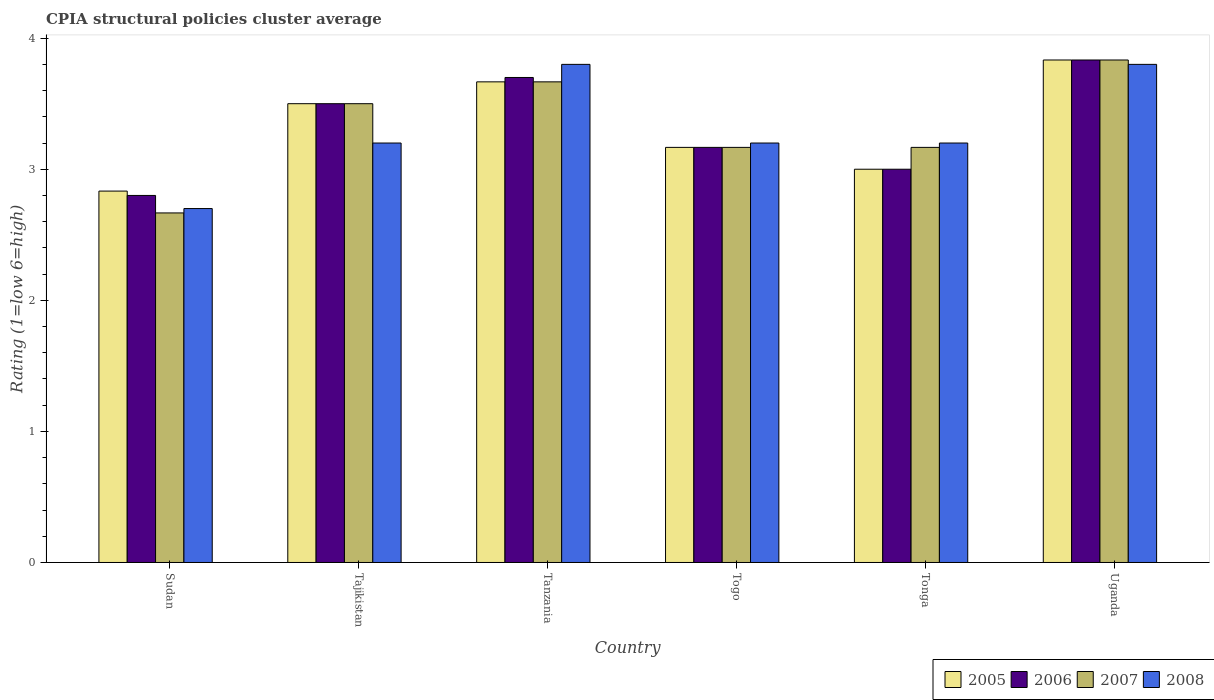Are the number of bars per tick equal to the number of legend labels?
Give a very brief answer. Yes. Are the number of bars on each tick of the X-axis equal?
Your answer should be compact. Yes. How many bars are there on the 2nd tick from the left?
Offer a terse response. 4. What is the label of the 1st group of bars from the left?
Make the answer very short. Sudan. In how many cases, is the number of bars for a given country not equal to the number of legend labels?
Your answer should be very brief. 0. What is the CPIA rating in 2007 in Togo?
Offer a terse response. 3.17. Across all countries, what is the maximum CPIA rating in 2005?
Make the answer very short. 3.83. Across all countries, what is the minimum CPIA rating in 2007?
Offer a terse response. 2.67. In which country was the CPIA rating in 2005 maximum?
Provide a short and direct response. Uganda. In which country was the CPIA rating in 2006 minimum?
Provide a short and direct response. Sudan. What is the total CPIA rating in 2008 in the graph?
Your answer should be compact. 19.9. What is the difference between the CPIA rating in 2008 in Togo and that in Uganda?
Ensure brevity in your answer.  -0.6. What is the difference between the CPIA rating in 2007 in Tanzania and the CPIA rating in 2005 in Togo?
Keep it short and to the point. 0.5. What is the average CPIA rating in 2007 per country?
Make the answer very short. 3.33. What is the difference between the CPIA rating of/in 2005 and CPIA rating of/in 2006 in Sudan?
Your response must be concise. 0.03. What is the ratio of the CPIA rating in 2007 in Tanzania to that in Tonga?
Your answer should be very brief. 1.16. What is the difference between the highest and the second highest CPIA rating in 2008?
Offer a terse response. -0.6. What is the difference between the highest and the lowest CPIA rating in 2008?
Provide a succinct answer. 1.1. In how many countries, is the CPIA rating in 2006 greater than the average CPIA rating in 2006 taken over all countries?
Keep it short and to the point. 3. Is the sum of the CPIA rating in 2008 in Tajikistan and Tonga greater than the maximum CPIA rating in 2007 across all countries?
Offer a very short reply. Yes. Is it the case that in every country, the sum of the CPIA rating in 2005 and CPIA rating in 2008 is greater than the sum of CPIA rating in 2006 and CPIA rating in 2007?
Your answer should be very brief. No. Is it the case that in every country, the sum of the CPIA rating in 2007 and CPIA rating in 2008 is greater than the CPIA rating in 2005?
Offer a terse response. Yes. How many bars are there?
Your answer should be compact. 24. Are all the bars in the graph horizontal?
Provide a short and direct response. No. How many countries are there in the graph?
Your response must be concise. 6. Does the graph contain grids?
Provide a short and direct response. No. Where does the legend appear in the graph?
Give a very brief answer. Bottom right. How many legend labels are there?
Provide a short and direct response. 4. How are the legend labels stacked?
Provide a succinct answer. Horizontal. What is the title of the graph?
Provide a short and direct response. CPIA structural policies cluster average. What is the Rating (1=low 6=high) in 2005 in Sudan?
Keep it short and to the point. 2.83. What is the Rating (1=low 6=high) in 2007 in Sudan?
Provide a short and direct response. 2.67. What is the Rating (1=low 6=high) in 2005 in Tajikistan?
Provide a short and direct response. 3.5. What is the Rating (1=low 6=high) of 2007 in Tajikistan?
Provide a succinct answer. 3.5. What is the Rating (1=low 6=high) in 2008 in Tajikistan?
Provide a short and direct response. 3.2. What is the Rating (1=low 6=high) of 2005 in Tanzania?
Ensure brevity in your answer.  3.67. What is the Rating (1=low 6=high) of 2006 in Tanzania?
Your response must be concise. 3.7. What is the Rating (1=low 6=high) of 2007 in Tanzania?
Give a very brief answer. 3.67. What is the Rating (1=low 6=high) in 2005 in Togo?
Your answer should be compact. 3.17. What is the Rating (1=low 6=high) of 2006 in Togo?
Your answer should be very brief. 3.17. What is the Rating (1=low 6=high) in 2007 in Togo?
Your answer should be compact. 3.17. What is the Rating (1=low 6=high) in 2007 in Tonga?
Your answer should be compact. 3.17. What is the Rating (1=low 6=high) of 2005 in Uganda?
Offer a terse response. 3.83. What is the Rating (1=low 6=high) of 2006 in Uganda?
Give a very brief answer. 3.83. What is the Rating (1=low 6=high) in 2007 in Uganda?
Provide a short and direct response. 3.83. What is the Rating (1=low 6=high) in 2008 in Uganda?
Your answer should be very brief. 3.8. Across all countries, what is the maximum Rating (1=low 6=high) in 2005?
Your answer should be compact. 3.83. Across all countries, what is the maximum Rating (1=low 6=high) of 2006?
Your answer should be compact. 3.83. Across all countries, what is the maximum Rating (1=low 6=high) in 2007?
Your response must be concise. 3.83. Across all countries, what is the maximum Rating (1=low 6=high) in 2008?
Offer a very short reply. 3.8. Across all countries, what is the minimum Rating (1=low 6=high) in 2005?
Offer a very short reply. 2.83. Across all countries, what is the minimum Rating (1=low 6=high) in 2007?
Offer a terse response. 2.67. Across all countries, what is the minimum Rating (1=low 6=high) of 2008?
Provide a short and direct response. 2.7. What is the total Rating (1=low 6=high) of 2007 in the graph?
Offer a terse response. 20. What is the total Rating (1=low 6=high) of 2008 in the graph?
Your answer should be compact. 19.9. What is the difference between the Rating (1=low 6=high) in 2005 in Sudan and that in Tanzania?
Make the answer very short. -0.83. What is the difference between the Rating (1=low 6=high) of 2007 in Sudan and that in Tanzania?
Your answer should be compact. -1. What is the difference between the Rating (1=low 6=high) of 2008 in Sudan and that in Tanzania?
Provide a short and direct response. -1.1. What is the difference between the Rating (1=low 6=high) of 2005 in Sudan and that in Togo?
Offer a terse response. -0.33. What is the difference between the Rating (1=low 6=high) of 2006 in Sudan and that in Togo?
Your response must be concise. -0.37. What is the difference between the Rating (1=low 6=high) in 2007 in Sudan and that in Togo?
Offer a very short reply. -0.5. What is the difference between the Rating (1=low 6=high) of 2008 in Sudan and that in Togo?
Make the answer very short. -0.5. What is the difference between the Rating (1=low 6=high) of 2005 in Sudan and that in Tonga?
Your answer should be compact. -0.17. What is the difference between the Rating (1=low 6=high) of 2007 in Sudan and that in Tonga?
Give a very brief answer. -0.5. What is the difference between the Rating (1=low 6=high) in 2008 in Sudan and that in Tonga?
Ensure brevity in your answer.  -0.5. What is the difference between the Rating (1=low 6=high) of 2006 in Sudan and that in Uganda?
Your answer should be compact. -1.03. What is the difference between the Rating (1=low 6=high) of 2007 in Sudan and that in Uganda?
Keep it short and to the point. -1.17. What is the difference between the Rating (1=low 6=high) of 2008 in Sudan and that in Uganda?
Keep it short and to the point. -1.1. What is the difference between the Rating (1=low 6=high) of 2005 in Tajikistan and that in Tanzania?
Offer a very short reply. -0.17. What is the difference between the Rating (1=low 6=high) of 2006 in Tajikistan and that in Tanzania?
Keep it short and to the point. -0.2. What is the difference between the Rating (1=low 6=high) in 2005 in Tajikistan and that in Togo?
Provide a succinct answer. 0.33. What is the difference between the Rating (1=low 6=high) in 2006 in Tajikistan and that in Togo?
Your answer should be very brief. 0.33. What is the difference between the Rating (1=low 6=high) in 2008 in Tajikistan and that in Togo?
Your response must be concise. 0. What is the difference between the Rating (1=low 6=high) in 2005 in Tajikistan and that in Tonga?
Ensure brevity in your answer.  0.5. What is the difference between the Rating (1=low 6=high) in 2006 in Tajikistan and that in Tonga?
Your answer should be compact. 0.5. What is the difference between the Rating (1=low 6=high) in 2006 in Tajikistan and that in Uganda?
Your answer should be compact. -0.33. What is the difference between the Rating (1=low 6=high) of 2007 in Tajikistan and that in Uganda?
Your response must be concise. -0.33. What is the difference between the Rating (1=low 6=high) in 2008 in Tajikistan and that in Uganda?
Make the answer very short. -0.6. What is the difference between the Rating (1=low 6=high) in 2006 in Tanzania and that in Togo?
Give a very brief answer. 0.53. What is the difference between the Rating (1=low 6=high) in 2007 in Tanzania and that in Togo?
Make the answer very short. 0.5. What is the difference between the Rating (1=low 6=high) of 2005 in Tanzania and that in Tonga?
Give a very brief answer. 0.67. What is the difference between the Rating (1=low 6=high) of 2006 in Tanzania and that in Tonga?
Keep it short and to the point. 0.7. What is the difference between the Rating (1=low 6=high) of 2007 in Tanzania and that in Tonga?
Make the answer very short. 0.5. What is the difference between the Rating (1=low 6=high) in 2006 in Tanzania and that in Uganda?
Offer a very short reply. -0.13. What is the difference between the Rating (1=low 6=high) in 2007 in Tanzania and that in Uganda?
Offer a very short reply. -0.17. What is the difference between the Rating (1=low 6=high) of 2008 in Tanzania and that in Uganda?
Your answer should be compact. 0. What is the difference between the Rating (1=low 6=high) in 2005 in Togo and that in Tonga?
Keep it short and to the point. 0.17. What is the difference between the Rating (1=low 6=high) in 2007 in Togo and that in Tonga?
Offer a very short reply. 0. What is the difference between the Rating (1=low 6=high) of 2005 in Togo and that in Uganda?
Keep it short and to the point. -0.67. What is the difference between the Rating (1=low 6=high) of 2006 in Tonga and that in Uganda?
Keep it short and to the point. -0.83. What is the difference between the Rating (1=low 6=high) in 2005 in Sudan and the Rating (1=low 6=high) in 2008 in Tajikistan?
Keep it short and to the point. -0.37. What is the difference between the Rating (1=low 6=high) of 2007 in Sudan and the Rating (1=low 6=high) of 2008 in Tajikistan?
Your response must be concise. -0.53. What is the difference between the Rating (1=low 6=high) in 2005 in Sudan and the Rating (1=low 6=high) in 2006 in Tanzania?
Your response must be concise. -0.87. What is the difference between the Rating (1=low 6=high) in 2005 in Sudan and the Rating (1=low 6=high) in 2008 in Tanzania?
Your response must be concise. -0.97. What is the difference between the Rating (1=low 6=high) in 2006 in Sudan and the Rating (1=low 6=high) in 2007 in Tanzania?
Your response must be concise. -0.87. What is the difference between the Rating (1=low 6=high) in 2006 in Sudan and the Rating (1=low 6=high) in 2008 in Tanzania?
Your response must be concise. -1. What is the difference between the Rating (1=low 6=high) of 2007 in Sudan and the Rating (1=low 6=high) of 2008 in Tanzania?
Keep it short and to the point. -1.13. What is the difference between the Rating (1=low 6=high) in 2005 in Sudan and the Rating (1=low 6=high) in 2007 in Togo?
Your answer should be compact. -0.33. What is the difference between the Rating (1=low 6=high) in 2005 in Sudan and the Rating (1=low 6=high) in 2008 in Togo?
Your response must be concise. -0.37. What is the difference between the Rating (1=low 6=high) of 2006 in Sudan and the Rating (1=low 6=high) of 2007 in Togo?
Provide a succinct answer. -0.37. What is the difference between the Rating (1=low 6=high) of 2007 in Sudan and the Rating (1=low 6=high) of 2008 in Togo?
Give a very brief answer. -0.53. What is the difference between the Rating (1=low 6=high) of 2005 in Sudan and the Rating (1=low 6=high) of 2007 in Tonga?
Provide a short and direct response. -0.33. What is the difference between the Rating (1=low 6=high) of 2005 in Sudan and the Rating (1=low 6=high) of 2008 in Tonga?
Provide a succinct answer. -0.37. What is the difference between the Rating (1=low 6=high) of 2006 in Sudan and the Rating (1=low 6=high) of 2007 in Tonga?
Make the answer very short. -0.37. What is the difference between the Rating (1=low 6=high) of 2006 in Sudan and the Rating (1=low 6=high) of 2008 in Tonga?
Provide a succinct answer. -0.4. What is the difference between the Rating (1=low 6=high) of 2007 in Sudan and the Rating (1=low 6=high) of 2008 in Tonga?
Provide a short and direct response. -0.53. What is the difference between the Rating (1=low 6=high) of 2005 in Sudan and the Rating (1=low 6=high) of 2007 in Uganda?
Keep it short and to the point. -1. What is the difference between the Rating (1=low 6=high) in 2005 in Sudan and the Rating (1=low 6=high) in 2008 in Uganda?
Your answer should be compact. -0.97. What is the difference between the Rating (1=low 6=high) of 2006 in Sudan and the Rating (1=low 6=high) of 2007 in Uganda?
Your response must be concise. -1.03. What is the difference between the Rating (1=low 6=high) in 2006 in Sudan and the Rating (1=low 6=high) in 2008 in Uganda?
Provide a short and direct response. -1. What is the difference between the Rating (1=low 6=high) of 2007 in Sudan and the Rating (1=low 6=high) of 2008 in Uganda?
Your answer should be compact. -1.13. What is the difference between the Rating (1=low 6=high) of 2005 in Tajikistan and the Rating (1=low 6=high) of 2006 in Tanzania?
Provide a succinct answer. -0.2. What is the difference between the Rating (1=low 6=high) of 2005 in Tajikistan and the Rating (1=low 6=high) of 2007 in Tanzania?
Ensure brevity in your answer.  -0.17. What is the difference between the Rating (1=low 6=high) in 2006 in Tajikistan and the Rating (1=low 6=high) in 2007 in Tanzania?
Offer a terse response. -0.17. What is the difference between the Rating (1=low 6=high) in 2005 in Tajikistan and the Rating (1=low 6=high) in 2006 in Togo?
Your answer should be very brief. 0.33. What is the difference between the Rating (1=low 6=high) of 2005 in Tajikistan and the Rating (1=low 6=high) of 2007 in Togo?
Provide a short and direct response. 0.33. What is the difference between the Rating (1=low 6=high) of 2006 in Tajikistan and the Rating (1=low 6=high) of 2008 in Togo?
Provide a short and direct response. 0.3. What is the difference between the Rating (1=low 6=high) in 2007 in Tajikistan and the Rating (1=low 6=high) in 2008 in Togo?
Give a very brief answer. 0.3. What is the difference between the Rating (1=low 6=high) of 2005 in Tajikistan and the Rating (1=low 6=high) of 2006 in Uganda?
Keep it short and to the point. -0.33. What is the difference between the Rating (1=low 6=high) in 2005 in Tajikistan and the Rating (1=low 6=high) in 2007 in Uganda?
Your answer should be compact. -0.33. What is the difference between the Rating (1=low 6=high) of 2006 in Tajikistan and the Rating (1=low 6=high) of 2008 in Uganda?
Your answer should be compact. -0.3. What is the difference between the Rating (1=low 6=high) of 2005 in Tanzania and the Rating (1=low 6=high) of 2008 in Togo?
Your response must be concise. 0.47. What is the difference between the Rating (1=low 6=high) of 2006 in Tanzania and the Rating (1=low 6=high) of 2007 in Togo?
Make the answer very short. 0.53. What is the difference between the Rating (1=low 6=high) of 2007 in Tanzania and the Rating (1=low 6=high) of 2008 in Togo?
Offer a terse response. 0.47. What is the difference between the Rating (1=low 6=high) of 2005 in Tanzania and the Rating (1=low 6=high) of 2006 in Tonga?
Keep it short and to the point. 0.67. What is the difference between the Rating (1=low 6=high) of 2005 in Tanzania and the Rating (1=low 6=high) of 2008 in Tonga?
Your response must be concise. 0.47. What is the difference between the Rating (1=low 6=high) in 2006 in Tanzania and the Rating (1=low 6=high) in 2007 in Tonga?
Your answer should be compact. 0.53. What is the difference between the Rating (1=low 6=high) of 2006 in Tanzania and the Rating (1=low 6=high) of 2008 in Tonga?
Offer a terse response. 0.5. What is the difference between the Rating (1=low 6=high) of 2007 in Tanzania and the Rating (1=low 6=high) of 2008 in Tonga?
Your answer should be compact. 0.47. What is the difference between the Rating (1=low 6=high) of 2005 in Tanzania and the Rating (1=low 6=high) of 2006 in Uganda?
Your answer should be compact. -0.17. What is the difference between the Rating (1=low 6=high) in 2005 in Tanzania and the Rating (1=low 6=high) in 2007 in Uganda?
Your answer should be very brief. -0.17. What is the difference between the Rating (1=low 6=high) in 2005 in Tanzania and the Rating (1=low 6=high) in 2008 in Uganda?
Offer a terse response. -0.13. What is the difference between the Rating (1=low 6=high) of 2006 in Tanzania and the Rating (1=low 6=high) of 2007 in Uganda?
Your answer should be compact. -0.13. What is the difference between the Rating (1=low 6=high) of 2006 in Tanzania and the Rating (1=low 6=high) of 2008 in Uganda?
Keep it short and to the point. -0.1. What is the difference between the Rating (1=low 6=high) in 2007 in Tanzania and the Rating (1=low 6=high) in 2008 in Uganda?
Your answer should be compact. -0.13. What is the difference between the Rating (1=low 6=high) of 2005 in Togo and the Rating (1=low 6=high) of 2006 in Tonga?
Provide a short and direct response. 0.17. What is the difference between the Rating (1=low 6=high) in 2005 in Togo and the Rating (1=low 6=high) in 2007 in Tonga?
Ensure brevity in your answer.  0. What is the difference between the Rating (1=low 6=high) in 2005 in Togo and the Rating (1=low 6=high) in 2008 in Tonga?
Offer a terse response. -0.03. What is the difference between the Rating (1=low 6=high) of 2006 in Togo and the Rating (1=low 6=high) of 2008 in Tonga?
Your answer should be compact. -0.03. What is the difference between the Rating (1=low 6=high) in 2007 in Togo and the Rating (1=low 6=high) in 2008 in Tonga?
Give a very brief answer. -0.03. What is the difference between the Rating (1=low 6=high) of 2005 in Togo and the Rating (1=low 6=high) of 2008 in Uganda?
Your answer should be compact. -0.63. What is the difference between the Rating (1=low 6=high) of 2006 in Togo and the Rating (1=low 6=high) of 2007 in Uganda?
Keep it short and to the point. -0.67. What is the difference between the Rating (1=low 6=high) in 2006 in Togo and the Rating (1=low 6=high) in 2008 in Uganda?
Your response must be concise. -0.63. What is the difference between the Rating (1=low 6=high) of 2007 in Togo and the Rating (1=low 6=high) of 2008 in Uganda?
Offer a terse response. -0.63. What is the difference between the Rating (1=low 6=high) in 2005 in Tonga and the Rating (1=low 6=high) in 2006 in Uganda?
Ensure brevity in your answer.  -0.83. What is the difference between the Rating (1=low 6=high) of 2006 in Tonga and the Rating (1=low 6=high) of 2007 in Uganda?
Provide a short and direct response. -0.83. What is the difference between the Rating (1=low 6=high) of 2006 in Tonga and the Rating (1=low 6=high) of 2008 in Uganda?
Ensure brevity in your answer.  -0.8. What is the difference between the Rating (1=low 6=high) of 2007 in Tonga and the Rating (1=low 6=high) of 2008 in Uganda?
Provide a succinct answer. -0.63. What is the average Rating (1=low 6=high) of 2007 per country?
Your answer should be very brief. 3.33. What is the average Rating (1=low 6=high) in 2008 per country?
Offer a terse response. 3.32. What is the difference between the Rating (1=low 6=high) of 2005 and Rating (1=low 6=high) of 2006 in Sudan?
Your answer should be compact. 0.03. What is the difference between the Rating (1=low 6=high) of 2005 and Rating (1=low 6=high) of 2008 in Sudan?
Give a very brief answer. 0.13. What is the difference between the Rating (1=low 6=high) in 2006 and Rating (1=low 6=high) in 2007 in Sudan?
Provide a short and direct response. 0.13. What is the difference between the Rating (1=low 6=high) of 2007 and Rating (1=low 6=high) of 2008 in Sudan?
Ensure brevity in your answer.  -0.03. What is the difference between the Rating (1=low 6=high) in 2005 and Rating (1=low 6=high) in 2008 in Tajikistan?
Offer a very short reply. 0.3. What is the difference between the Rating (1=low 6=high) in 2005 and Rating (1=low 6=high) in 2006 in Tanzania?
Provide a succinct answer. -0.03. What is the difference between the Rating (1=low 6=high) of 2005 and Rating (1=low 6=high) of 2008 in Tanzania?
Make the answer very short. -0.13. What is the difference between the Rating (1=low 6=high) in 2007 and Rating (1=low 6=high) in 2008 in Tanzania?
Make the answer very short. -0.13. What is the difference between the Rating (1=low 6=high) in 2005 and Rating (1=low 6=high) in 2006 in Togo?
Offer a terse response. 0. What is the difference between the Rating (1=low 6=high) in 2005 and Rating (1=low 6=high) in 2007 in Togo?
Offer a very short reply. 0. What is the difference between the Rating (1=low 6=high) in 2005 and Rating (1=low 6=high) in 2008 in Togo?
Provide a short and direct response. -0.03. What is the difference between the Rating (1=low 6=high) in 2006 and Rating (1=low 6=high) in 2007 in Togo?
Your answer should be very brief. 0. What is the difference between the Rating (1=low 6=high) of 2006 and Rating (1=low 6=high) of 2008 in Togo?
Your answer should be very brief. -0.03. What is the difference between the Rating (1=low 6=high) of 2007 and Rating (1=low 6=high) of 2008 in Togo?
Your answer should be compact. -0.03. What is the difference between the Rating (1=low 6=high) of 2005 and Rating (1=low 6=high) of 2006 in Tonga?
Give a very brief answer. 0. What is the difference between the Rating (1=low 6=high) in 2005 and Rating (1=low 6=high) in 2007 in Tonga?
Provide a succinct answer. -0.17. What is the difference between the Rating (1=low 6=high) of 2005 and Rating (1=low 6=high) of 2008 in Tonga?
Keep it short and to the point. -0.2. What is the difference between the Rating (1=low 6=high) of 2006 and Rating (1=low 6=high) of 2007 in Tonga?
Your answer should be compact. -0.17. What is the difference between the Rating (1=low 6=high) of 2006 and Rating (1=low 6=high) of 2008 in Tonga?
Offer a very short reply. -0.2. What is the difference between the Rating (1=low 6=high) in 2007 and Rating (1=low 6=high) in 2008 in Tonga?
Provide a short and direct response. -0.03. What is the difference between the Rating (1=low 6=high) of 2005 and Rating (1=low 6=high) of 2006 in Uganda?
Make the answer very short. 0. What is the difference between the Rating (1=low 6=high) of 2005 and Rating (1=low 6=high) of 2008 in Uganda?
Your answer should be very brief. 0.03. What is the difference between the Rating (1=low 6=high) in 2006 and Rating (1=low 6=high) in 2007 in Uganda?
Ensure brevity in your answer.  0. What is the ratio of the Rating (1=low 6=high) in 2005 in Sudan to that in Tajikistan?
Offer a terse response. 0.81. What is the ratio of the Rating (1=low 6=high) in 2007 in Sudan to that in Tajikistan?
Your answer should be very brief. 0.76. What is the ratio of the Rating (1=low 6=high) in 2008 in Sudan to that in Tajikistan?
Keep it short and to the point. 0.84. What is the ratio of the Rating (1=low 6=high) of 2005 in Sudan to that in Tanzania?
Ensure brevity in your answer.  0.77. What is the ratio of the Rating (1=low 6=high) in 2006 in Sudan to that in Tanzania?
Offer a terse response. 0.76. What is the ratio of the Rating (1=low 6=high) in 2007 in Sudan to that in Tanzania?
Your response must be concise. 0.73. What is the ratio of the Rating (1=low 6=high) in 2008 in Sudan to that in Tanzania?
Offer a terse response. 0.71. What is the ratio of the Rating (1=low 6=high) in 2005 in Sudan to that in Togo?
Your answer should be compact. 0.89. What is the ratio of the Rating (1=low 6=high) in 2006 in Sudan to that in Togo?
Give a very brief answer. 0.88. What is the ratio of the Rating (1=low 6=high) in 2007 in Sudan to that in Togo?
Make the answer very short. 0.84. What is the ratio of the Rating (1=low 6=high) in 2008 in Sudan to that in Togo?
Keep it short and to the point. 0.84. What is the ratio of the Rating (1=low 6=high) in 2006 in Sudan to that in Tonga?
Your response must be concise. 0.93. What is the ratio of the Rating (1=low 6=high) in 2007 in Sudan to that in Tonga?
Offer a terse response. 0.84. What is the ratio of the Rating (1=low 6=high) of 2008 in Sudan to that in Tonga?
Offer a very short reply. 0.84. What is the ratio of the Rating (1=low 6=high) of 2005 in Sudan to that in Uganda?
Offer a very short reply. 0.74. What is the ratio of the Rating (1=low 6=high) in 2006 in Sudan to that in Uganda?
Offer a terse response. 0.73. What is the ratio of the Rating (1=low 6=high) in 2007 in Sudan to that in Uganda?
Offer a very short reply. 0.7. What is the ratio of the Rating (1=low 6=high) in 2008 in Sudan to that in Uganda?
Provide a succinct answer. 0.71. What is the ratio of the Rating (1=low 6=high) of 2005 in Tajikistan to that in Tanzania?
Your response must be concise. 0.95. What is the ratio of the Rating (1=low 6=high) in 2006 in Tajikistan to that in Tanzania?
Provide a short and direct response. 0.95. What is the ratio of the Rating (1=low 6=high) in 2007 in Tajikistan to that in Tanzania?
Your response must be concise. 0.95. What is the ratio of the Rating (1=low 6=high) of 2008 in Tajikistan to that in Tanzania?
Your response must be concise. 0.84. What is the ratio of the Rating (1=low 6=high) in 2005 in Tajikistan to that in Togo?
Provide a succinct answer. 1.11. What is the ratio of the Rating (1=low 6=high) in 2006 in Tajikistan to that in Togo?
Offer a very short reply. 1.11. What is the ratio of the Rating (1=low 6=high) of 2007 in Tajikistan to that in Togo?
Your answer should be compact. 1.11. What is the ratio of the Rating (1=low 6=high) in 2006 in Tajikistan to that in Tonga?
Ensure brevity in your answer.  1.17. What is the ratio of the Rating (1=low 6=high) in 2007 in Tajikistan to that in Tonga?
Ensure brevity in your answer.  1.11. What is the ratio of the Rating (1=low 6=high) of 2008 in Tajikistan to that in Uganda?
Your answer should be compact. 0.84. What is the ratio of the Rating (1=low 6=high) of 2005 in Tanzania to that in Togo?
Your answer should be very brief. 1.16. What is the ratio of the Rating (1=low 6=high) in 2006 in Tanzania to that in Togo?
Give a very brief answer. 1.17. What is the ratio of the Rating (1=low 6=high) in 2007 in Tanzania to that in Togo?
Ensure brevity in your answer.  1.16. What is the ratio of the Rating (1=low 6=high) in 2008 in Tanzania to that in Togo?
Ensure brevity in your answer.  1.19. What is the ratio of the Rating (1=low 6=high) of 2005 in Tanzania to that in Tonga?
Ensure brevity in your answer.  1.22. What is the ratio of the Rating (1=low 6=high) of 2006 in Tanzania to that in Tonga?
Keep it short and to the point. 1.23. What is the ratio of the Rating (1=low 6=high) in 2007 in Tanzania to that in Tonga?
Offer a very short reply. 1.16. What is the ratio of the Rating (1=low 6=high) of 2008 in Tanzania to that in Tonga?
Provide a short and direct response. 1.19. What is the ratio of the Rating (1=low 6=high) in 2005 in Tanzania to that in Uganda?
Give a very brief answer. 0.96. What is the ratio of the Rating (1=low 6=high) of 2006 in Tanzania to that in Uganda?
Offer a very short reply. 0.97. What is the ratio of the Rating (1=low 6=high) of 2007 in Tanzania to that in Uganda?
Provide a short and direct response. 0.96. What is the ratio of the Rating (1=low 6=high) of 2008 in Tanzania to that in Uganda?
Give a very brief answer. 1. What is the ratio of the Rating (1=low 6=high) of 2005 in Togo to that in Tonga?
Your response must be concise. 1.06. What is the ratio of the Rating (1=low 6=high) in 2006 in Togo to that in Tonga?
Offer a terse response. 1.06. What is the ratio of the Rating (1=low 6=high) of 2005 in Togo to that in Uganda?
Ensure brevity in your answer.  0.83. What is the ratio of the Rating (1=low 6=high) of 2006 in Togo to that in Uganda?
Your response must be concise. 0.83. What is the ratio of the Rating (1=low 6=high) in 2007 in Togo to that in Uganda?
Offer a very short reply. 0.83. What is the ratio of the Rating (1=low 6=high) in 2008 in Togo to that in Uganda?
Provide a short and direct response. 0.84. What is the ratio of the Rating (1=low 6=high) of 2005 in Tonga to that in Uganda?
Your answer should be compact. 0.78. What is the ratio of the Rating (1=low 6=high) of 2006 in Tonga to that in Uganda?
Provide a succinct answer. 0.78. What is the ratio of the Rating (1=low 6=high) of 2007 in Tonga to that in Uganda?
Keep it short and to the point. 0.83. What is the ratio of the Rating (1=low 6=high) of 2008 in Tonga to that in Uganda?
Your response must be concise. 0.84. What is the difference between the highest and the second highest Rating (1=low 6=high) of 2005?
Ensure brevity in your answer.  0.17. What is the difference between the highest and the second highest Rating (1=low 6=high) in 2006?
Keep it short and to the point. 0.13. What is the difference between the highest and the second highest Rating (1=low 6=high) in 2007?
Your response must be concise. 0.17. What is the difference between the highest and the lowest Rating (1=low 6=high) in 2005?
Offer a very short reply. 1. What is the difference between the highest and the lowest Rating (1=low 6=high) of 2007?
Provide a short and direct response. 1.17. What is the difference between the highest and the lowest Rating (1=low 6=high) of 2008?
Keep it short and to the point. 1.1. 